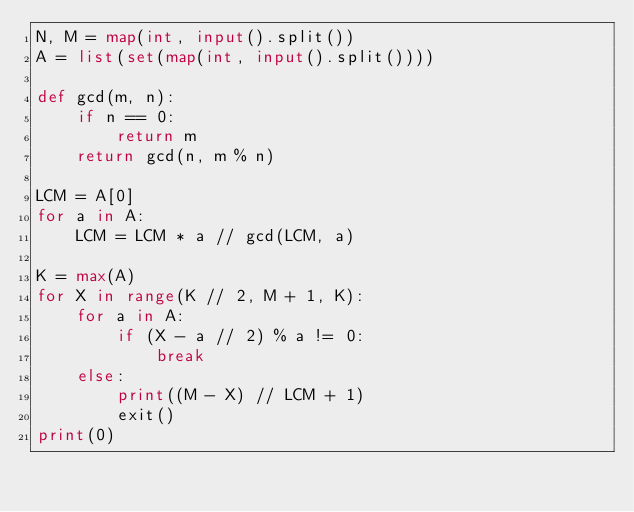<code> <loc_0><loc_0><loc_500><loc_500><_Python_>N, M = map(int, input().split())
A = list(set(map(int, input().split())))

def gcd(m, n):
    if n == 0:
        return m
    return gcd(n, m % n)

LCM = A[0]
for a in A:
    LCM = LCM * a // gcd(LCM, a)

K = max(A)
for X in range(K // 2, M + 1, K):
    for a in A:
        if (X - a // 2) % a != 0:
            break
    else:
        print((M - X) // LCM + 1)
        exit()
print(0)
</code> 